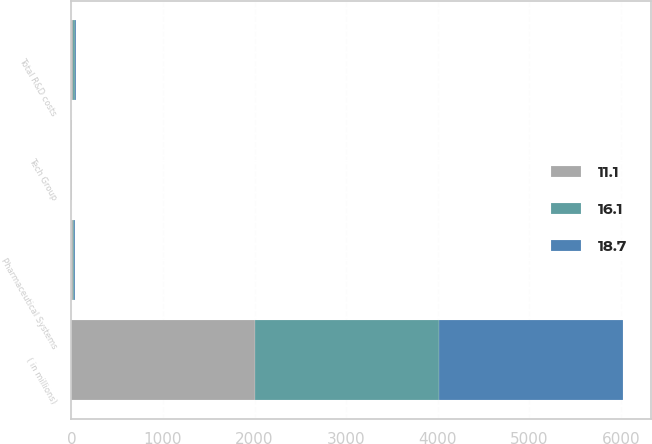Convert chart. <chart><loc_0><loc_0><loc_500><loc_500><stacked_bar_chart><ecel><fcel>( in millions)<fcel>Pharmaceutical Systems<fcel>Tech Group<fcel>Total R&D costs<nl><fcel>16.1<fcel>2008<fcel>17.2<fcel>1.5<fcel>18.7<nl><fcel>11.1<fcel>2007<fcel>14<fcel>2.1<fcel>16.1<nl><fcel>18.7<fcel>2006<fcel>8.7<fcel>2.4<fcel>11.1<nl></chart> 